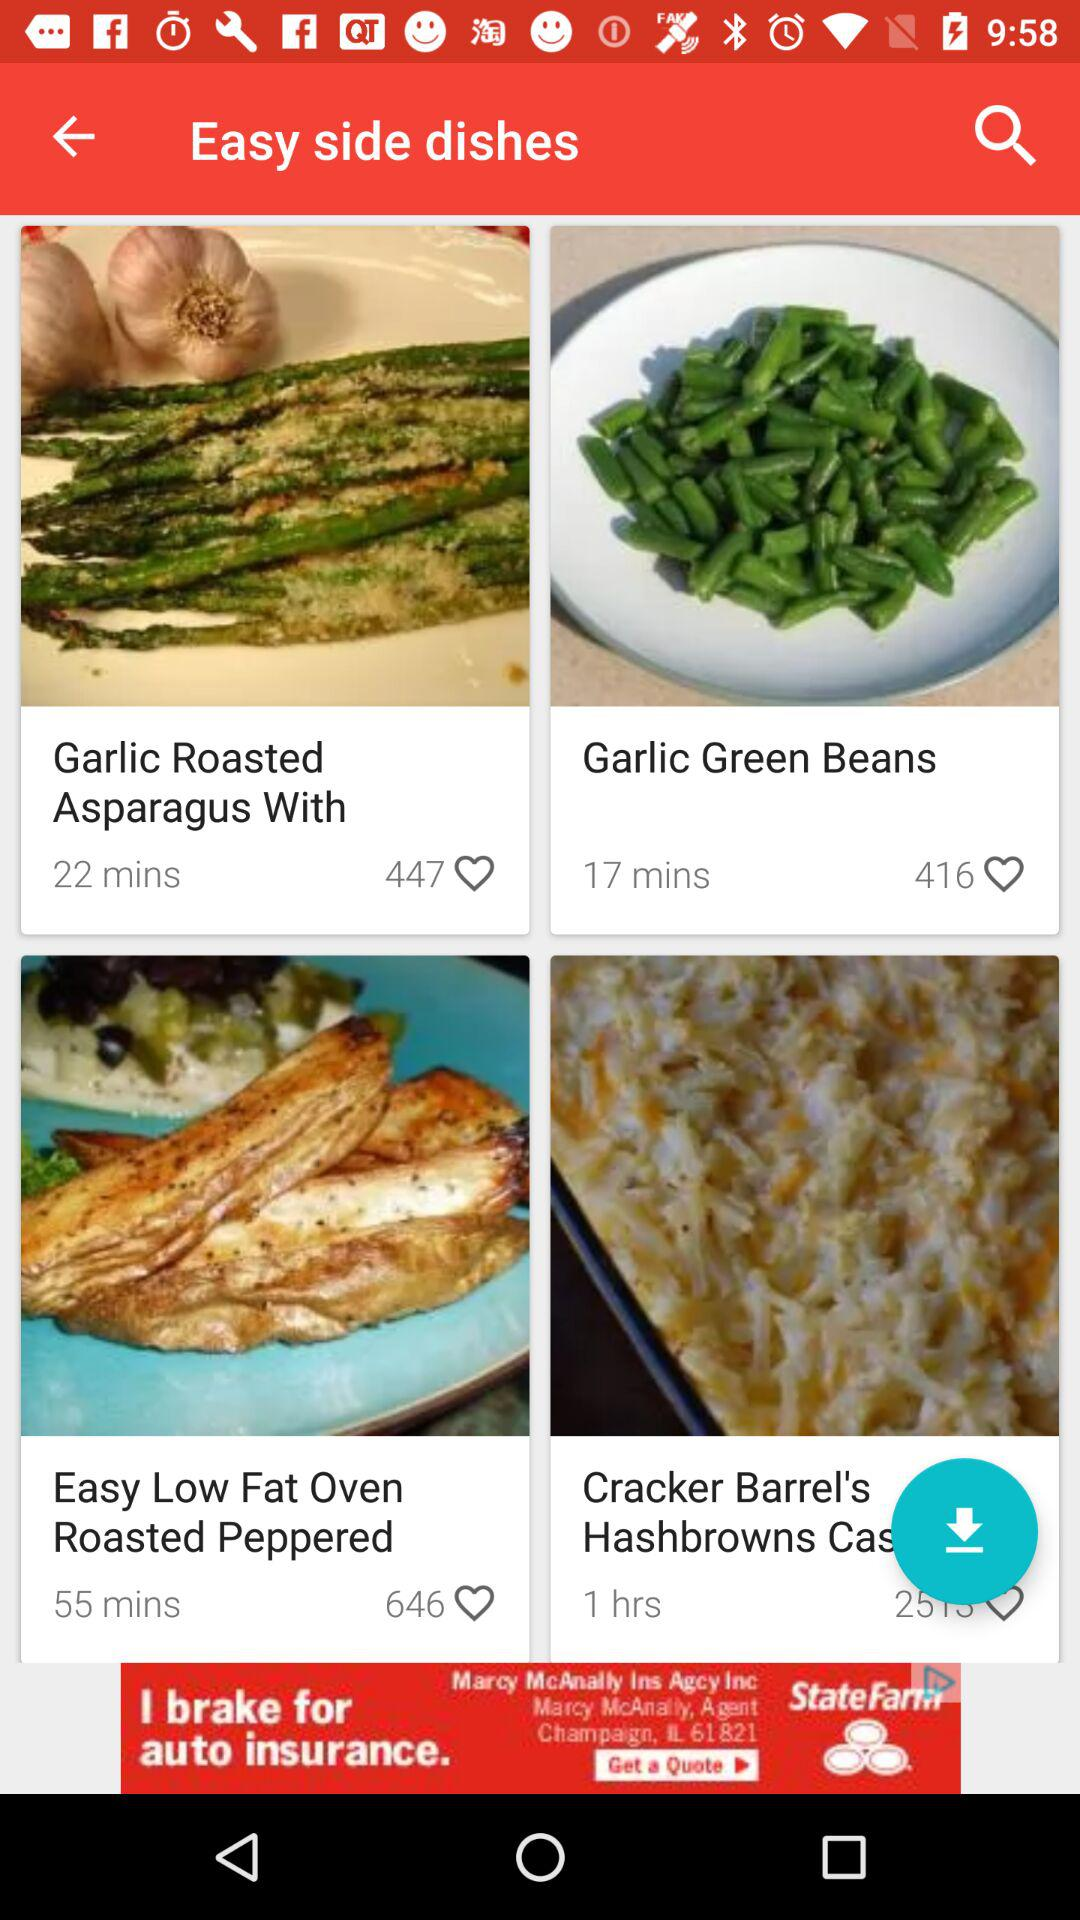Which dish has 447 likes? The dish that has 447 likes is "Garlic Roasted Asparagus With". 